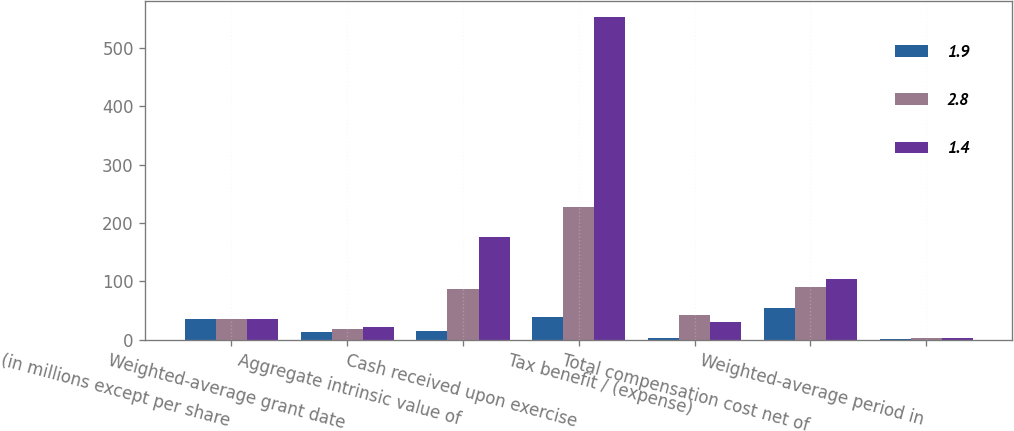Convert chart. <chart><loc_0><loc_0><loc_500><loc_500><stacked_bar_chart><ecel><fcel>(in millions except per share<fcel>Weighted-average grant date<fcel>Aggregate intrinsic value of<fcel>Cash received upon exercise<fcel>Tax benefit / (expense)<fcel>Total compensation cost net of<fcel>Weighted-average period in<nl><fcel>1.9<fcel>34.6<fcel>13.67<fcel>14<fcel>39.3<fcel>2.9<fcel>54.3<fcel>1.4<nl><fcel>2.8<fcel>34.6<fcel>17.82<fcel>87.3<fcel>227.9<fcel>42.1<fcel>89.5<fcel>1.9<nl><fcel>1.4<fcel>34.6<fcel>21.29<fcel>175.6<fcel>552.6<fcel>29.9<fcel>103<fcel>2.8<nl></chart> 